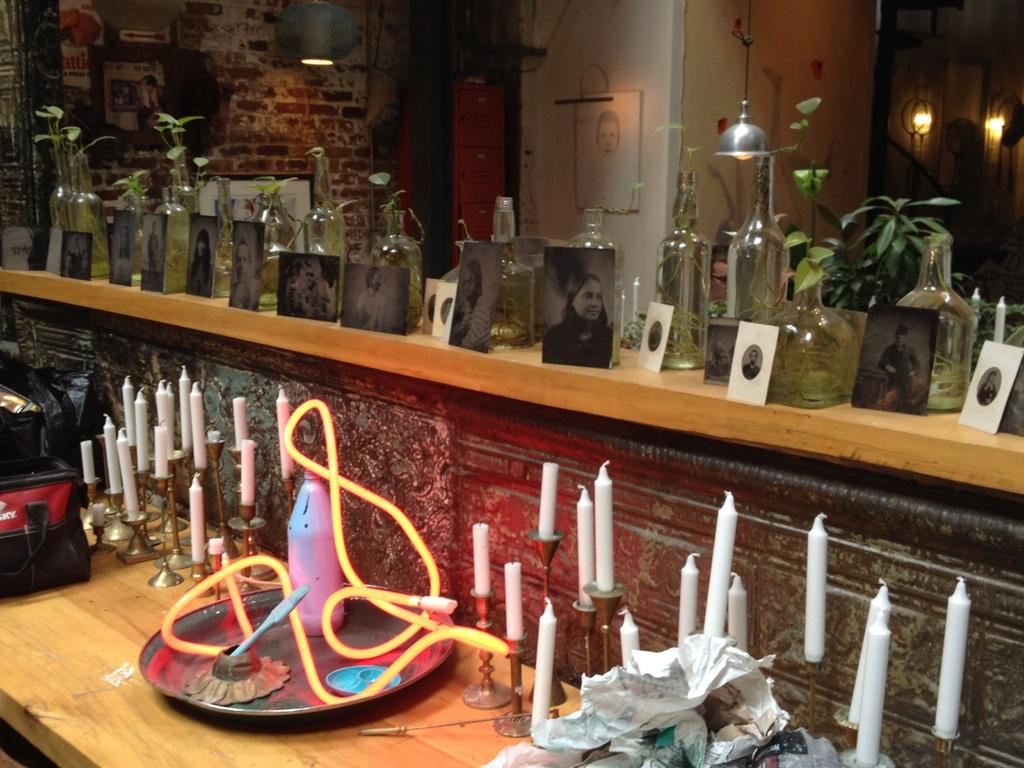What object can be seen in the image that might contain a liquid? There is a bottle in the image that might contain a liquid. What items are present on the table in the image? There are candles on a table in the image. What type of background is visible in the image? There is a wall visible in the image. What source of illumination is present in the image? There is a light in the image. How does the baby react to the impulse in the image? There is no baby or impulse present in the image. 